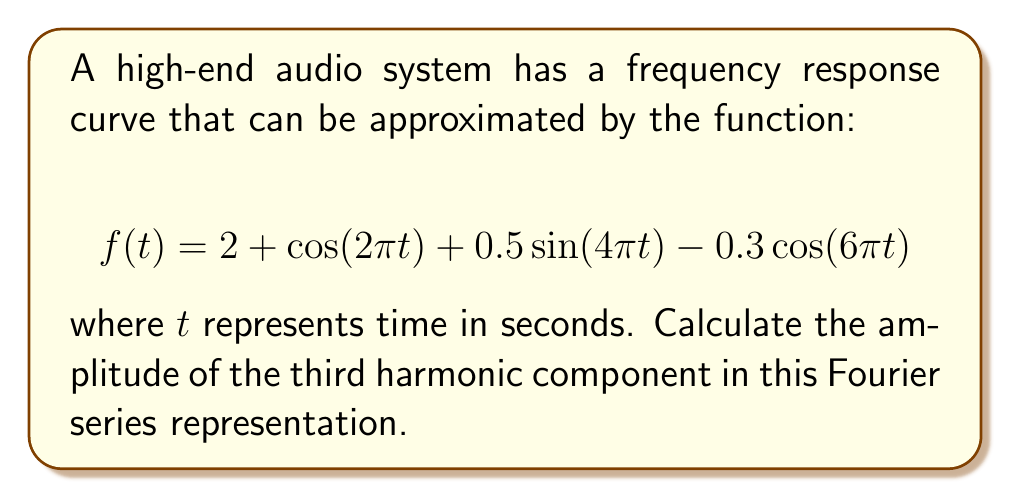Give your solution to this math problem. To solve this problem, we need to analyze the given Fourier series representation of the frequency response curve:

1) The general form of a Fourier series is:

   $$f(t) = a_0 + \sum_{n=1}^{\infty} (a_n \cos(n\omega t) + b_n \sin(n\omega t))$$

   where $a_0$ is the constant term, and $a_n$ and $b_n$ are the amplitudes of the cosine and sine terms respectively.

2) Comparing our given function to this general form:

   $$f(t) = 2 + \cos(2\pi t) + 0.5\sin(4\pi t) - 0.3\cos(6\pi t)$$

3) We can identify:
   - $a_0 = 2$
   - $a_1 = 1$ (coefficient of $\cos(2\pi t)$)
   - $b_2 = 0.5$ (coefficient of $\sin(4\pi t)$)
   - $a_3 = -0.3$ (coefficient of $\cos(6\pi t)$)

4) The third harmonic corresponds to the terms with $3\omega t$, which in this case is $6\pi t$.

5) The amplitude of a harmonic is given by $\sqrt{a_n^2 + b_n^2}$, where $a_n$ and $b_n$ are the coefficients of the cosine and sine terms respectively for that harmonic.

6) For the third harmonic, we have $a_3 = -0.3$ and $b_3 = 0$ (since there's no sine term for the third harmonic).

7) Therefore, the amplitude of the third harmonic is:

   $$\sqrt{(-0.3)^2 + 0^2} = 0.3$$
Answer: 0.3 